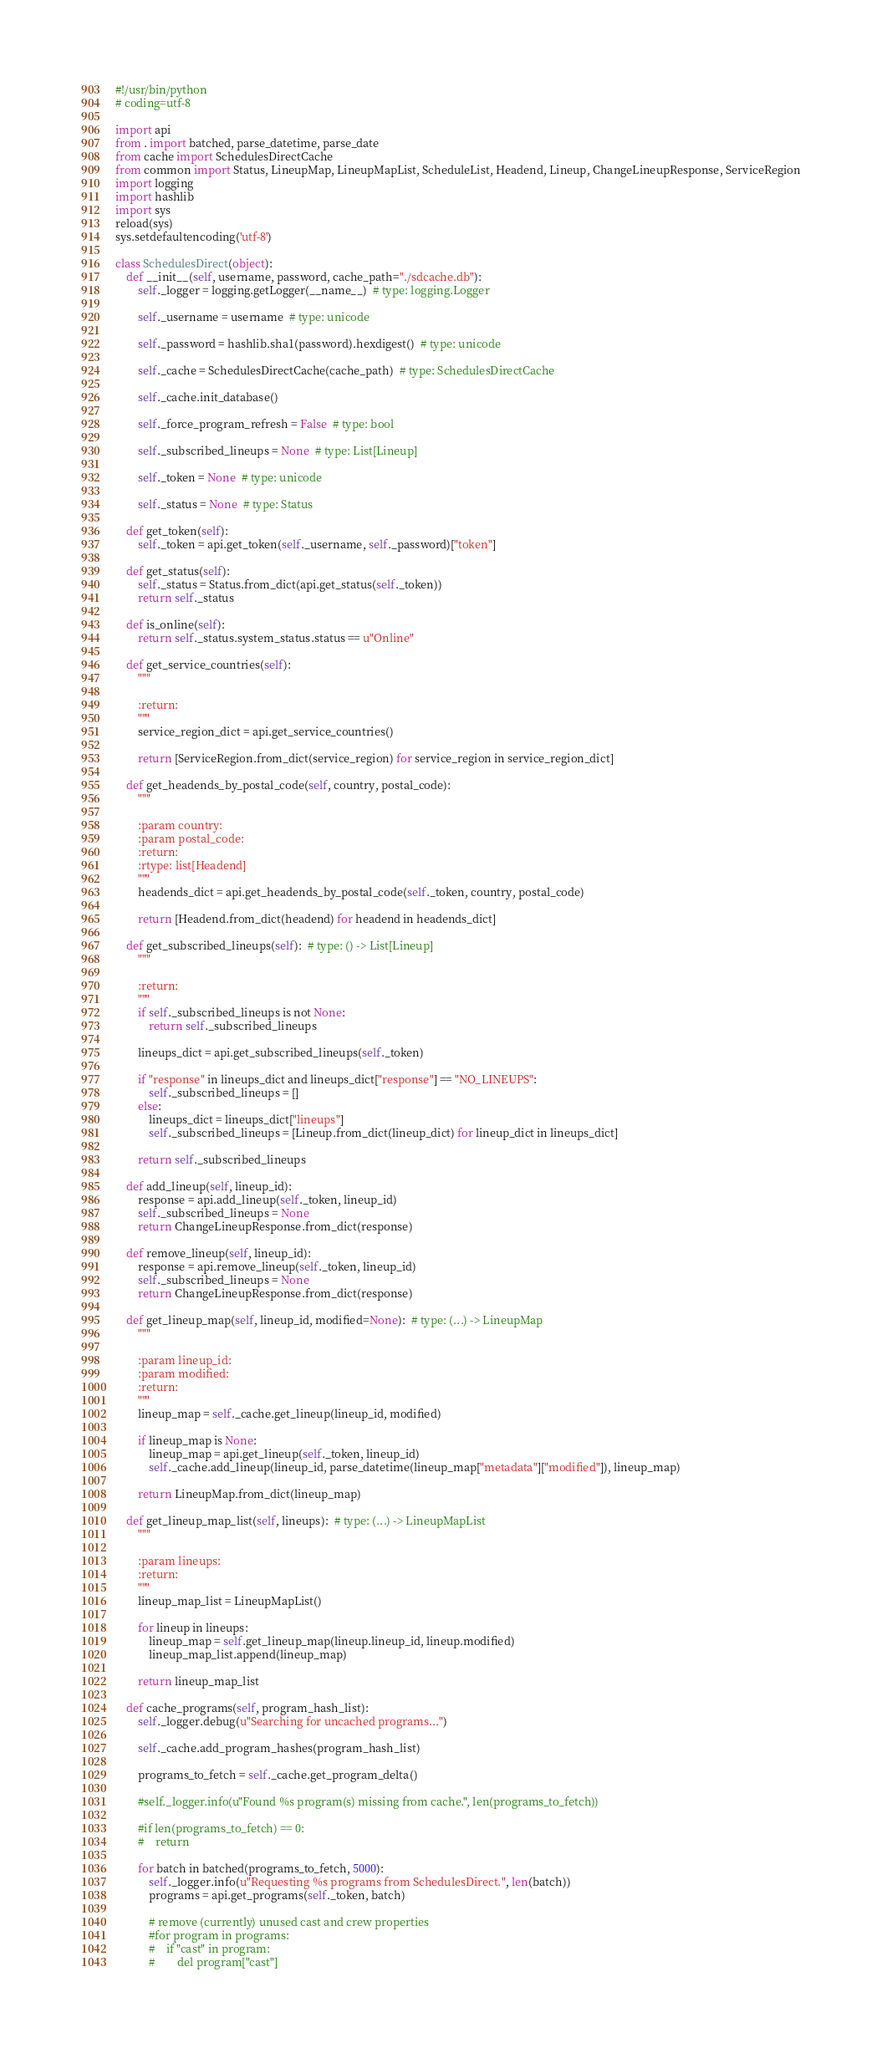Convert code to text. <code><loc_0><loc_0><loc_500><loc_500><_Python_>#!/usr/bin/python
# coding=utf-8

import api
from . import batched, parse_datetime, parse_date
from cache import SchedulesDirectCache
from common import Status, LineupMap, LineupMapList, ScheduleList, Headend, Lineup, ChangeLineupResponse, ServiceRegion
import logging
import hashlib
import sys
reload(sys)
sys.setdefaultencoding('utf-8')

class SchedulesDirect(object):
    def __init__(self, username, password, cache_path="./sdcache.db"):
        self._logger = logging.getLogger(__name__)  # type: logging.Logger

        self._username = username  # type: unicode

        self._password = hashlib.sha1(password).hexdigest()  # type: unicode

        self._cache = SchedulesDirectCache(cache_path)  # type: SchedulesDirectCache

        self._cache.init_database()

        self._force_program_refresh = False  # type: bool

        self._subscribed_lineups = None  # type: List[Lineup]

        self._token = None  # type: unicode

        self._status = None  # type: Status

    def get_token(self):
        self._token = api.get_token(self._username, self._password)["token"]

    def get_status(self):
        self._status = Status.from_dict(api.get_status(self._token))
        return self._status

    def is_online(self):
        return self._status.system_status.status == u"Online"

    def get_service_countries(self):
        """

        :return:
        """
        service_region_dict = api.get_service_countries()

        return [ServiceRegion.from_dict(service_region) for service_region in service_region_dict]

    def get_headends_by_postal_code(self, country, postal_code):
        """

        :param country:
        :param postal_code:
        :return:
        :rtype: list[Headend]
        """
        headends_dict = api.get_headends_by_postal_code(self._token, country, postal_code)

        return [Headend.from_dict(headend) for headend in headends_dict]

    def get_subscribed_lineups(self):  # type: () -> List[Lineup]
        """

        :return:
        """
        if self._subscribed_lineups is not None:
            return self._subscribed_lineups

        lineups_dict = api.get_subscribed_lineups(self._token)

        if "response" in lineups_dict and lineups_dict["response"] == "NO_LINEUPS":
            self._subscribed_lineups = []
        else:
            lineups_dict = lineups_dict["lineups"]
            self._subscribed_lineups = [Lineup.from_dict(lineup_dict) for lineup_dict in lineups_dict]

        return self._subscribed_lineups

    def add_lineup(self, lineup_id):
        response = api.add_lineup(self._token, lineup_id)
        self._subscribed_lineups = None
        return ChangeLineupResponse.from_dict(response)

    def remove_lineup(self, lineup_id):
        response = api.remove_lineup(self._token, lineup_id)
        self._subscribed_lineups = None
        return ChangeLineupResponse.from_dict(response)

    def get_lineup_map(self, lineup_id, modified=None):  # type: (...) -> LineupMap
        """

        :param lineup_id:
        :param modified:
        :return:
        """
        lineup_map = self._cache.get_lineup(lineup_id, modified)

        if lineup_map is None:
            lineup_map = api.get_lineup(self._token, lineup_id)
            self._cache.add_lineup(lineup_id, parse_datetime(lineup_map["metadata"]["modified"]), lineup_map)

        return LineupMap.from_dict(lineup_map)

    def get_lineup_map_list(self, lineups):  # type: (...) -> LineupMapList
        """

        :param lineups:
        :return:
        """
        lineup_map_list = LineupMapList()

        for lineup in lineups:
            lineup_map = self.get_lineup_map(lineup.lineup_id, lineup.modified)
            lineup_map_list.append(lineup_map)

        return lineup_map_list

    def cache_programs(self, program_hash_list):
        self._logger.debug(u"Searching for uncached programs...")

        self._cache.add_program_hashes(program_hash_list)

        programs_to_fetch = self._cache.get_program_delta()

        #self._logger.info(u"Found %s program(s) missing from cache.", len(programs_to_fetch))

        #if len(programs_to_fetch) == 0:
        #    return

        for batch in batched(programs_to_fetch, 5000):
            self._logger.info(u"Requesting %s programs from SchedulesDirect.", len(batch))
            programs = api.get_programs(self._token, batch)

            # remove (currently) unused cast and crew properties
            #for program in programs:
            #    if "cast" in program:
            #        del program["cast"]</code> 